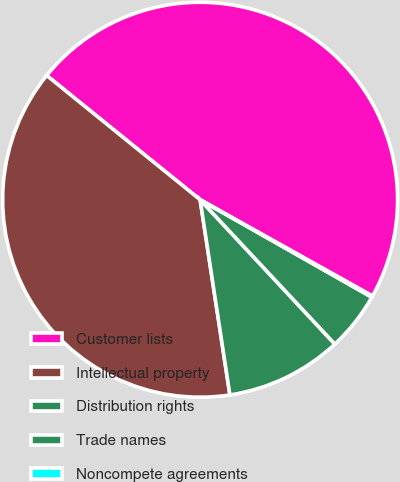<chart> <loc_0><loc_0><loc_500><loc_500><pie_chart><fcel>Customer lists<fcel>Intellectual property<fcel>Distribution rights<fcel>Trade names<fcel>Noncompete agreements<nl><fcel>47.27%<fcel>38.24%<fcel>9.54%<fcel>4.83%<fcel>0.11%<nl></chart> 